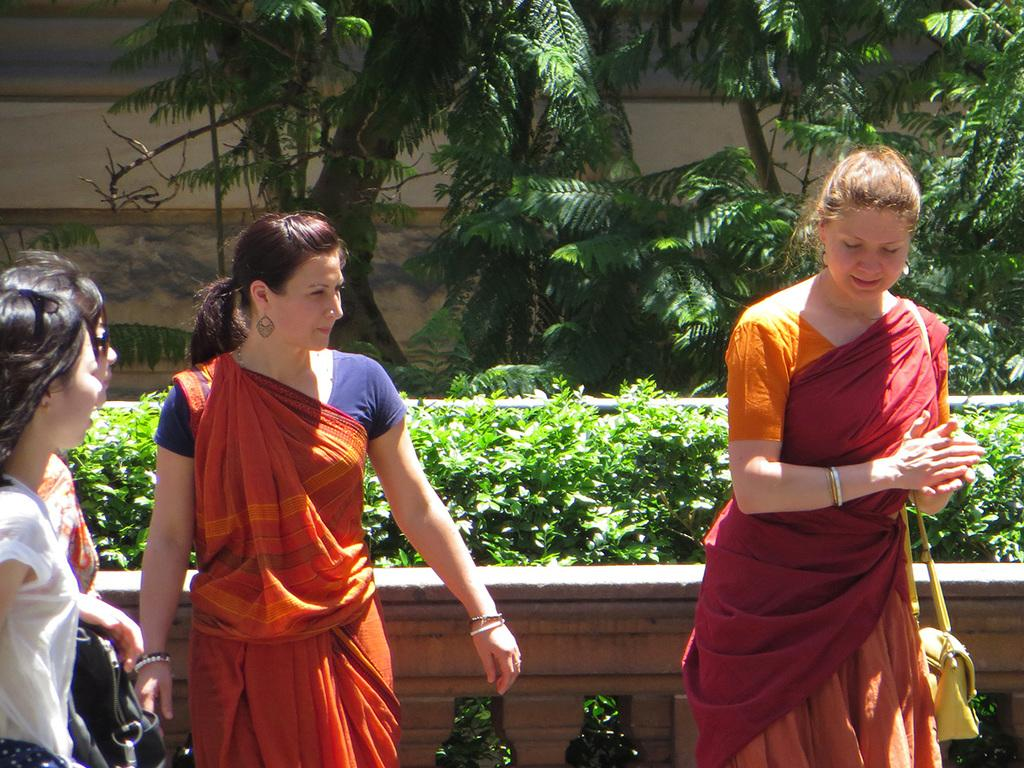What can be seen in the image in terms of human figures? There are human figures standing in the image. What type of clothing are some of the women wearing? Some of the women are wearing sarees. Can you describe any accessories worn by the women? One woman is wearing a handbag. What type of natural elements can be seen in the image? There are trees visible in the image. What type of man-made structure is present in the image? There is a building in the image. What type of vegetation can be seen in the image besides trees? There are plants in the image. What type of machine can be seen operating in the image? There is no machine present in the image; it features human figures, sarees, a handbag, trees, a building, and plants. What type of lace can be seen adorning the trees in the image? There is no lace present on the trees in the image; they are natural elements with no adornments. 